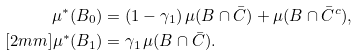Convert formula to latex. <formula><loc_0><loc_0><loc_500><loc_500>\mu ^ { * } ( B _ { 0 } ) & = ( 1 - \gamma _ { 1 } ) \, \mu ( B \cap \bar { C } ) + \mu ( B \cap \bar { C } ^ { c } ) , \\ [ 2 m m ] \mu ^ { * } ( B _ { 1 } ) & = \gamma _ { 1 } \, \mu ( B \cap \bar { C } ) .</formula> 